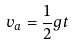Convert formula to latex. <formula><loc_0><loc_0><loc_500><loc_500>v _ { a } = \frac { 1 } { 2 } g t</formula> 